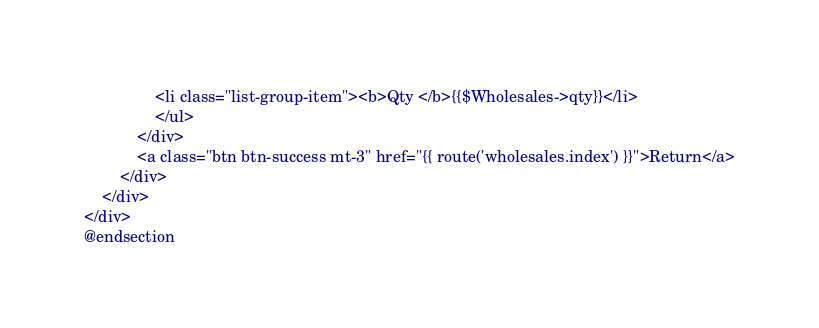<code> <loc_0><loc_0><loc_500><loc_500><_PHP_>                <li class="list-group-item"><b>Qty </b>{{$Wholesales->qty}}</li>
                </ul>
            </div>
            <a class="btn btn-success mt-3" href="{{ route('wholesales.index') }}">Return</a>
        </div>
    </div>
</div>
@endsection
</code> 